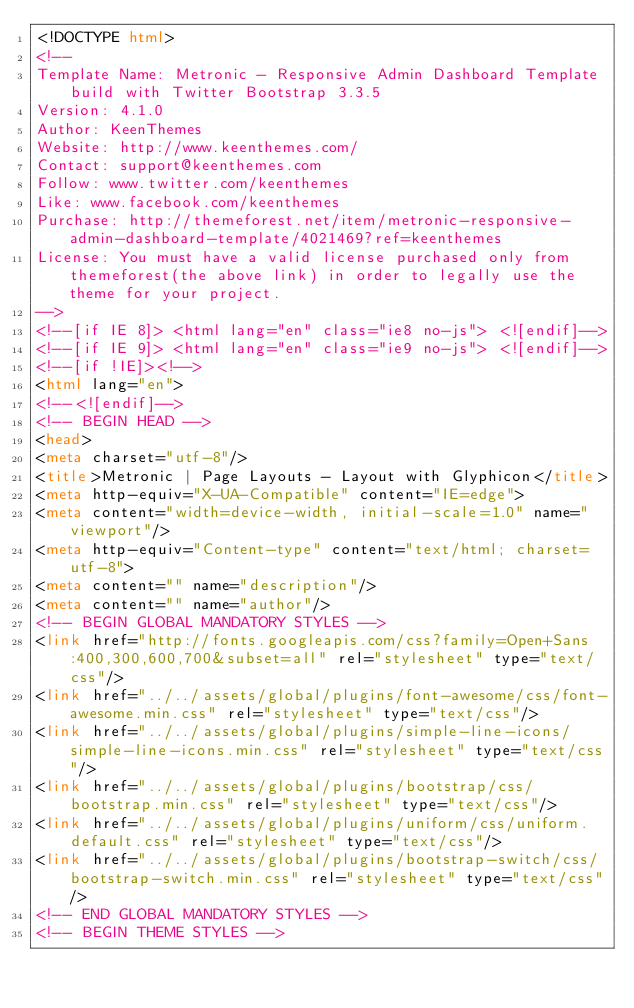Convert code to text. <code><loc_0><loc_0><loc_500><loc_500><_HTML_><!DOCTYPE html>
<!-- 
Template Name: Metronic - Responsive Admin Dashboard Template build with Twitter Bootstrap 3.3.5
Version: 4.1.0
Author: KeenThemes
Website: http://www.keenthemes.com/
Contact: support@keenthemes.com
Follow: www.twitter.com/keenthemes
Like: www.facebook.com/keenthemes
Purchase: http://themeforest.net/item/metronic-responsive-admin-dashboard-template/4021469?ref=keenthemes
License: You must have a valid license purchased only from themeforest(the above link) in order to legally use the theme for your project.
-->
<!--[if IE 8]> <html lang="en" class="ie8 no-js"> <![endif]-->
<!--[if IE 9]> <html lang="en" class="ie9 no-js"> <![endif]-->
<!--[if !IE]><!-->
<html lang="en">
<!--<![endif]-->
<!-- BEGIN HEAD -->
<head>
<meta charset="utf-8"/>
<title>Metronic | Page Layouts - Layout with Glyphicon</title>
<meta http-equiv="X-UA-Compatible" content="IE=edge">
<meta content="width=device-width, initial-scale=1.0" name="viewport"/>
<meta http-equiv="Content-type" content="text/html; charset=utf-8">
<meta content="" name="description"/>
<meta content="" name="author"/>
<!-- BEGIN GLOBAL MANDATORY STYLES -->
<link href="http://fonts.googleapis.com/css?family=Open+Sans:400,300,600,700&subset=all" rel="stylesheet" type="text/css"/>
<link href="../../assets/global/plugins/font-awesome/css/font-awesome.min.css" rel="stylesheet" type="text/css"/>
<link href="../../assets/global/plugins/simple-line-icons/simple-line-icons.min.css" rel="stylesheet" type="text/css"/>
<link href="../../assets/global/plugins/bootstrap/css/bootstrap.min.css" rel="stylesheet" type="text/css"/>
<link href="../../assets/global/plugins/uniform/css/uniform.default.css" rel="stylesheet" type="text/css"/>
<link href="../../assets/global/plugins/bootstrap-switch/css/bootstrap-switch.min.css" rel="stylesheet" type="text/css"/>
<!-- END GLOBAL MANDATORY STYLES -->
<!-- BEGIN THEME STYLES --></code> 